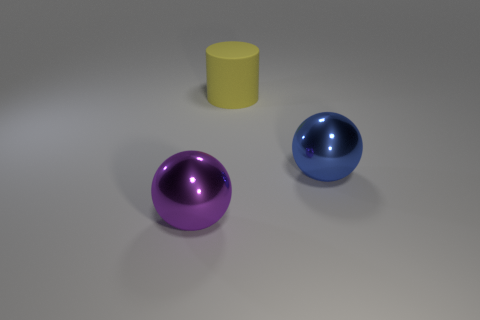Add 1 tiny metallic balls. How many objects exist? 4 Subtract all balls. How many objects are left? 1 Add 1 large yellow rubber cylinders. How many large yellow rubber cylinders exist? 2 Subtract 1 purple balls. How many objects are left? 2 Subtract all big blue metal balls. Subtract all large balls. How many objects are left? 0 Add 2 yellow rubber cylinders. How many yellow rubber cylinders are left? 3 